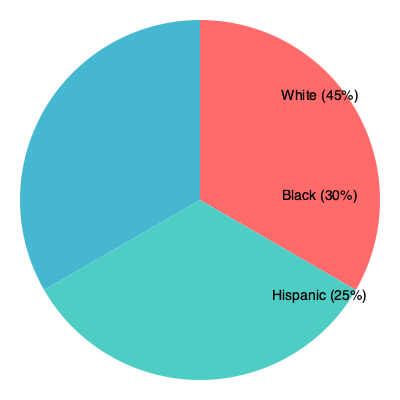The pie chart above represents the distribution of single-parent households across different demographic groups in a particular urban area. Based on this information, what percentage of single-parent households in this area are from minority groups (Black and Hispanic combined)? To solve this problem, we need to follow these steps:

1. Identify the minority groups in the given data:
   - Black (30%)
   - Hispanic (25%)

2. Add the percentages of these minority groups:
   $30\% + 25\% = 55\%$

3. Verify the result:
   - White (majority group): 45%
   - Minority groups (Black + Hispanic): 55%
   - Total: $45\% + 55\% = 100\%$

The sum of all percentages equals 100%, confirming our calculation is correct.

Therefore, the percentage of single-parent households from minority groups (Black and Hispanic combined) in this urban area is 55%.

This information is crucial for social workers and advocates for single parents, as it highlights the disproportionate representation of minority groups in single-parent households. This data can be used to inform policy decisions, allocate resources, and develop targeted support programs for these communities.
Answer: 55% 